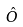<formula> <loc_0><loc_0><loc_500><loc_500>\hat { O }</formula> 